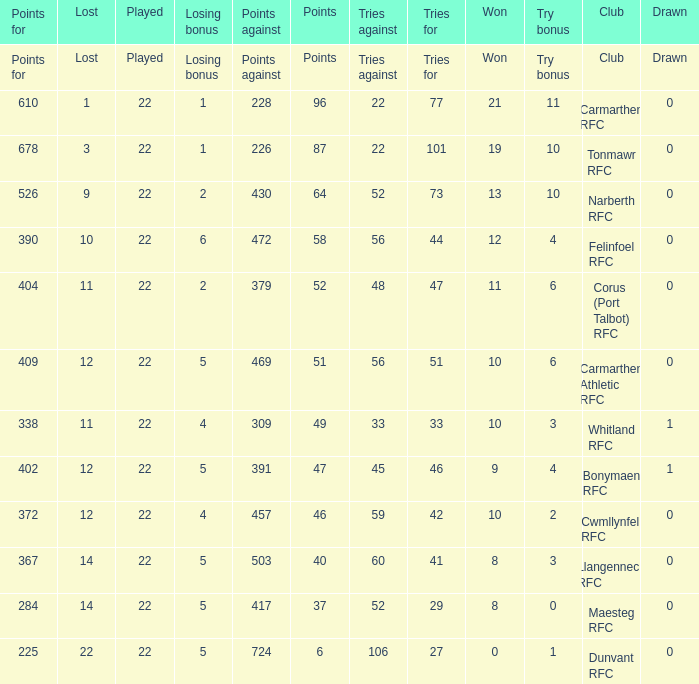Name the tries against for 87 points 22.0. 